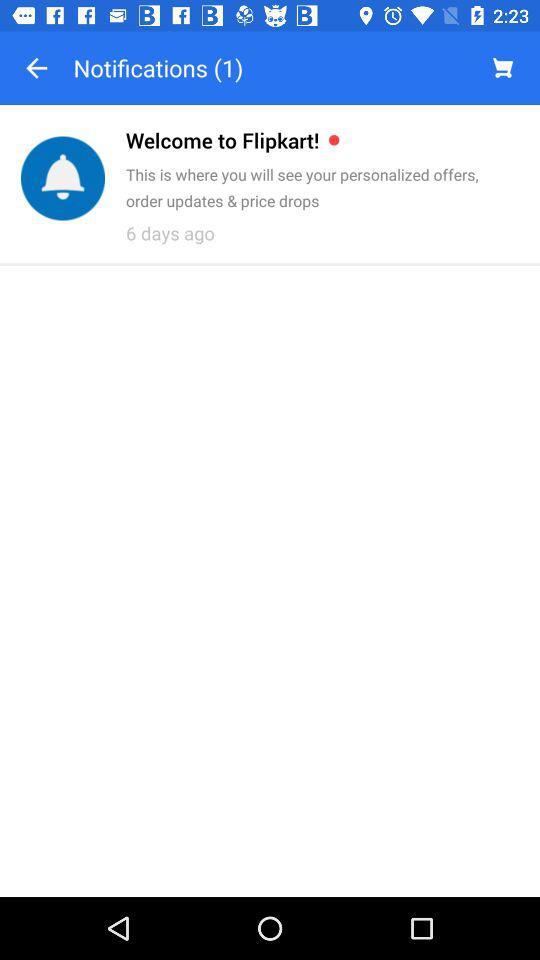How many more notifications do I have than shopping cart items?
Answer the question using a single word or phrase. 1 